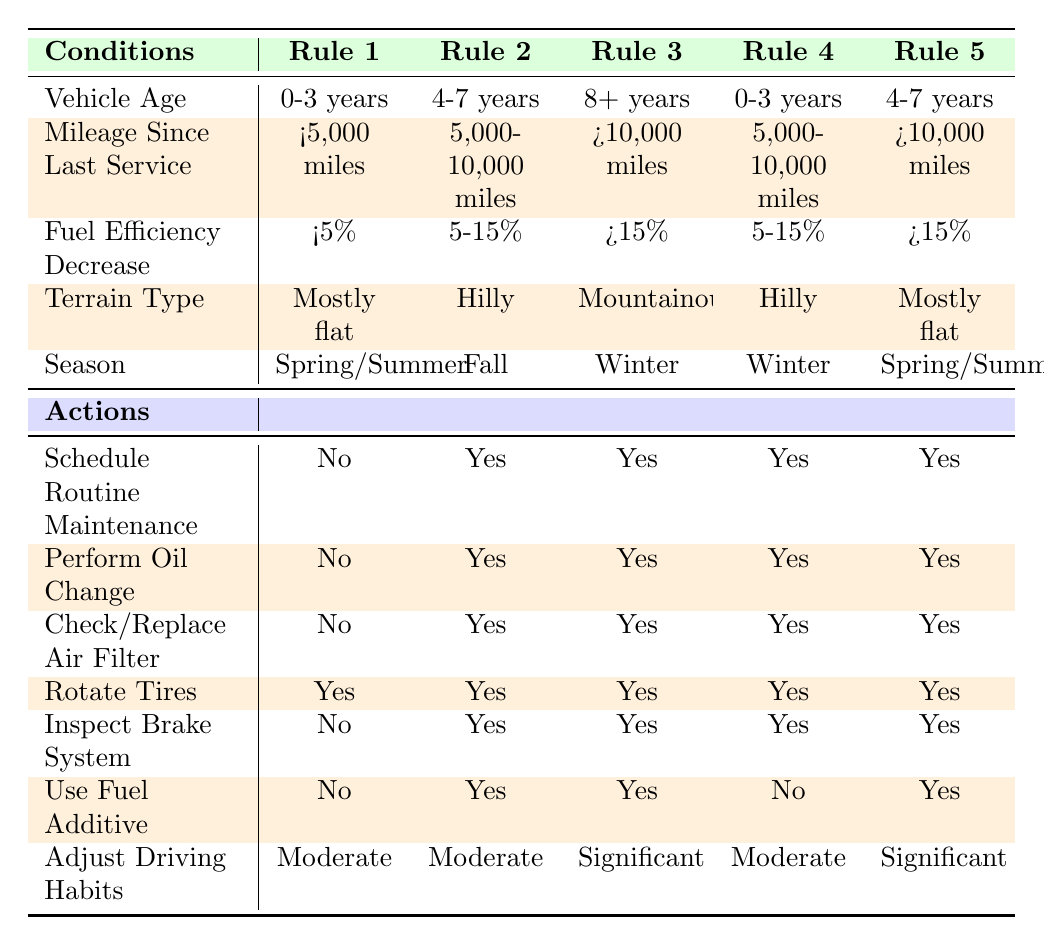What actions should be taken for a vehicle that is 4-7 years old, has mileage between 5,000-10,000 miles, experiences a fuel efficiency decrease of 5-15%, operates on hilly terrain, and is in the Fall season? In Rule 2, the conditions match the specified vehicle characteristics exactly. The actions listed are: Schedule Routine Maintenance (Yes), Perform Oil Change (Yes), Check/Replace Air Filter (Yes), Rotate Tires (Yes), Inspect Brake System (Yes), Use Fuel Additive (Yes), and Adjust Driving Habits (Moderate).
Answer: Yes, schedule routine maintenance, perform an oil change, check/replace air filter, rotate tires, inspect brake system, use fuel additive, and adjust driving habits to moderate Is a routine maintenance schedule necessary for a vehicle older than 8 years with mileage over 10,000 miles and a fuel efficiency decrease greater than 15% when driving in mountainous terrain during winter? According to Rule 3, these conditions apply to the vehicle, and the action specifies that routine maintenance should be scheduled (Yes).
Answer: Yes If a vehicle is 0-3 years old and has less than 5,000 miles since the last service, how many actions require taking? For the conditions of 0-3 years and <5,000 miles from Rule 1, the actions are: Schedule Routine Maintenance (No), Perform Oil Change (No), Check/Replace Air Filter (No), Rotate Tires (Yes), Inspect Brake System (No), Use Fuel Additive (No), Adjust Driving Habits (Moderate). Counting only the actions that require taking action (Yes), there is just 1 action which is Rotate Tires.
Answer: 1 action For which condition is it recommended to use a fuel additive? There are two rules that mention using a fuel additive: in Rule 2 and Rule 5, both of which check for conditions involving vehicles older than 4 years. This suggests it's necessary when dealing with older vehicles experiencing specific problems.
Answer: It is recommended to use a fuel additive when the vehicle is 4-7 years old with specific mileage and terrain conditions or if it is older than 4 years with specific mileage If a vehicle is in the Winter season and is 0-3 years old with a mileage of 5,000-10,000 miles and a fuel efficiency decrease of 5-15%, what actions are necessary? Referring to Rule 4, the conditions provided fit perfectly. The corresponding actions are: Schedule Routine Maintenance (Yes), Perform Oil Change (Yes), Check/Replace Air Filter (Yes), Rotate Tires (Yes), Inspect Brake System (Yes), Use Fuel Additive (No), Adjust Driving Habits (Moderate).
Answer: Yes, schedule maintenance, perform oil change, check air filter, rotate tires, and inspect the brake system 